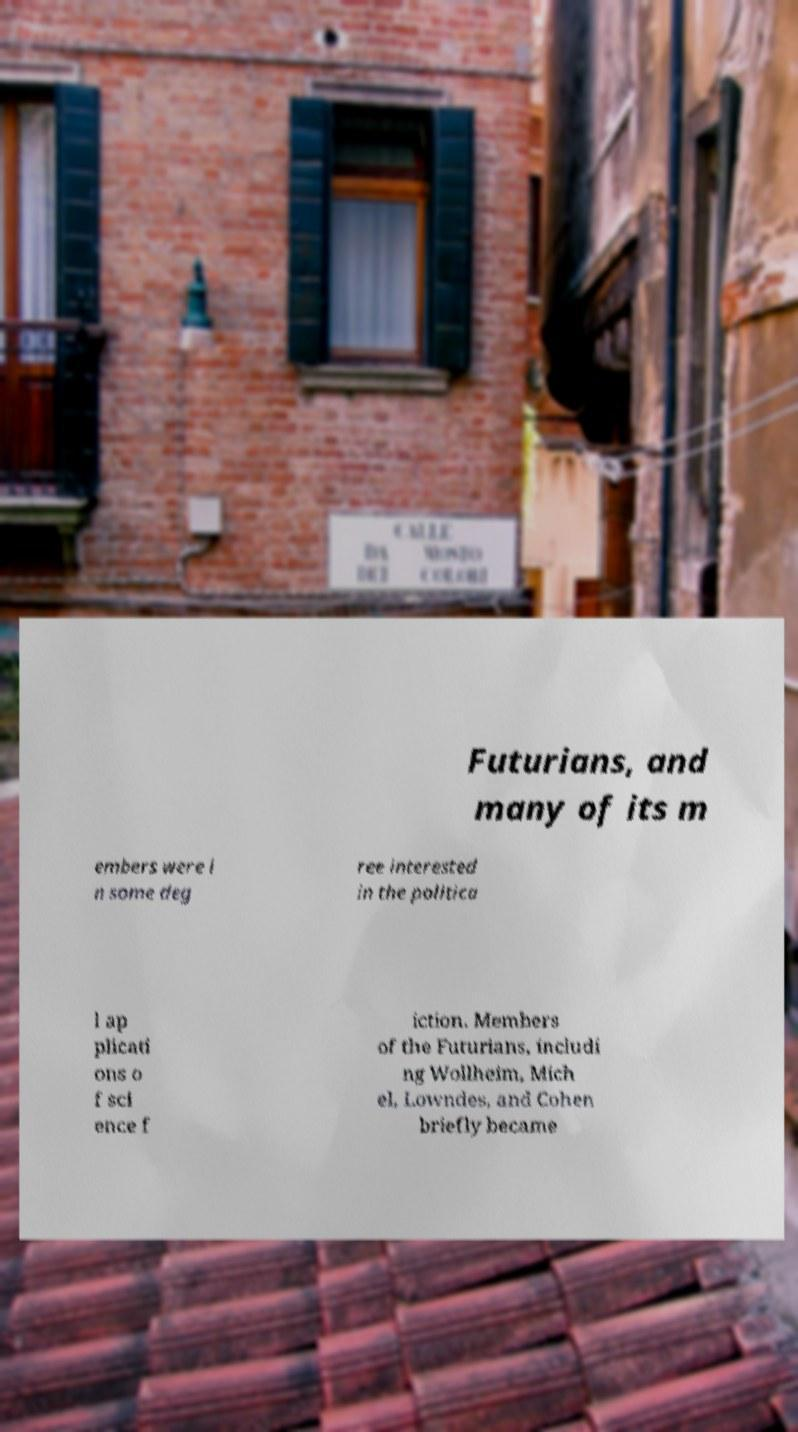I need the written content from this picture converted into text. Can you do that? Futurians, and many of its m embers were i n some deg ree interested in the politica l ap plicati ons o f sci ence f iction. Members of the Futurians, includi ng Wollheim, Mich el, Lowndes, and Cohen briefly became 